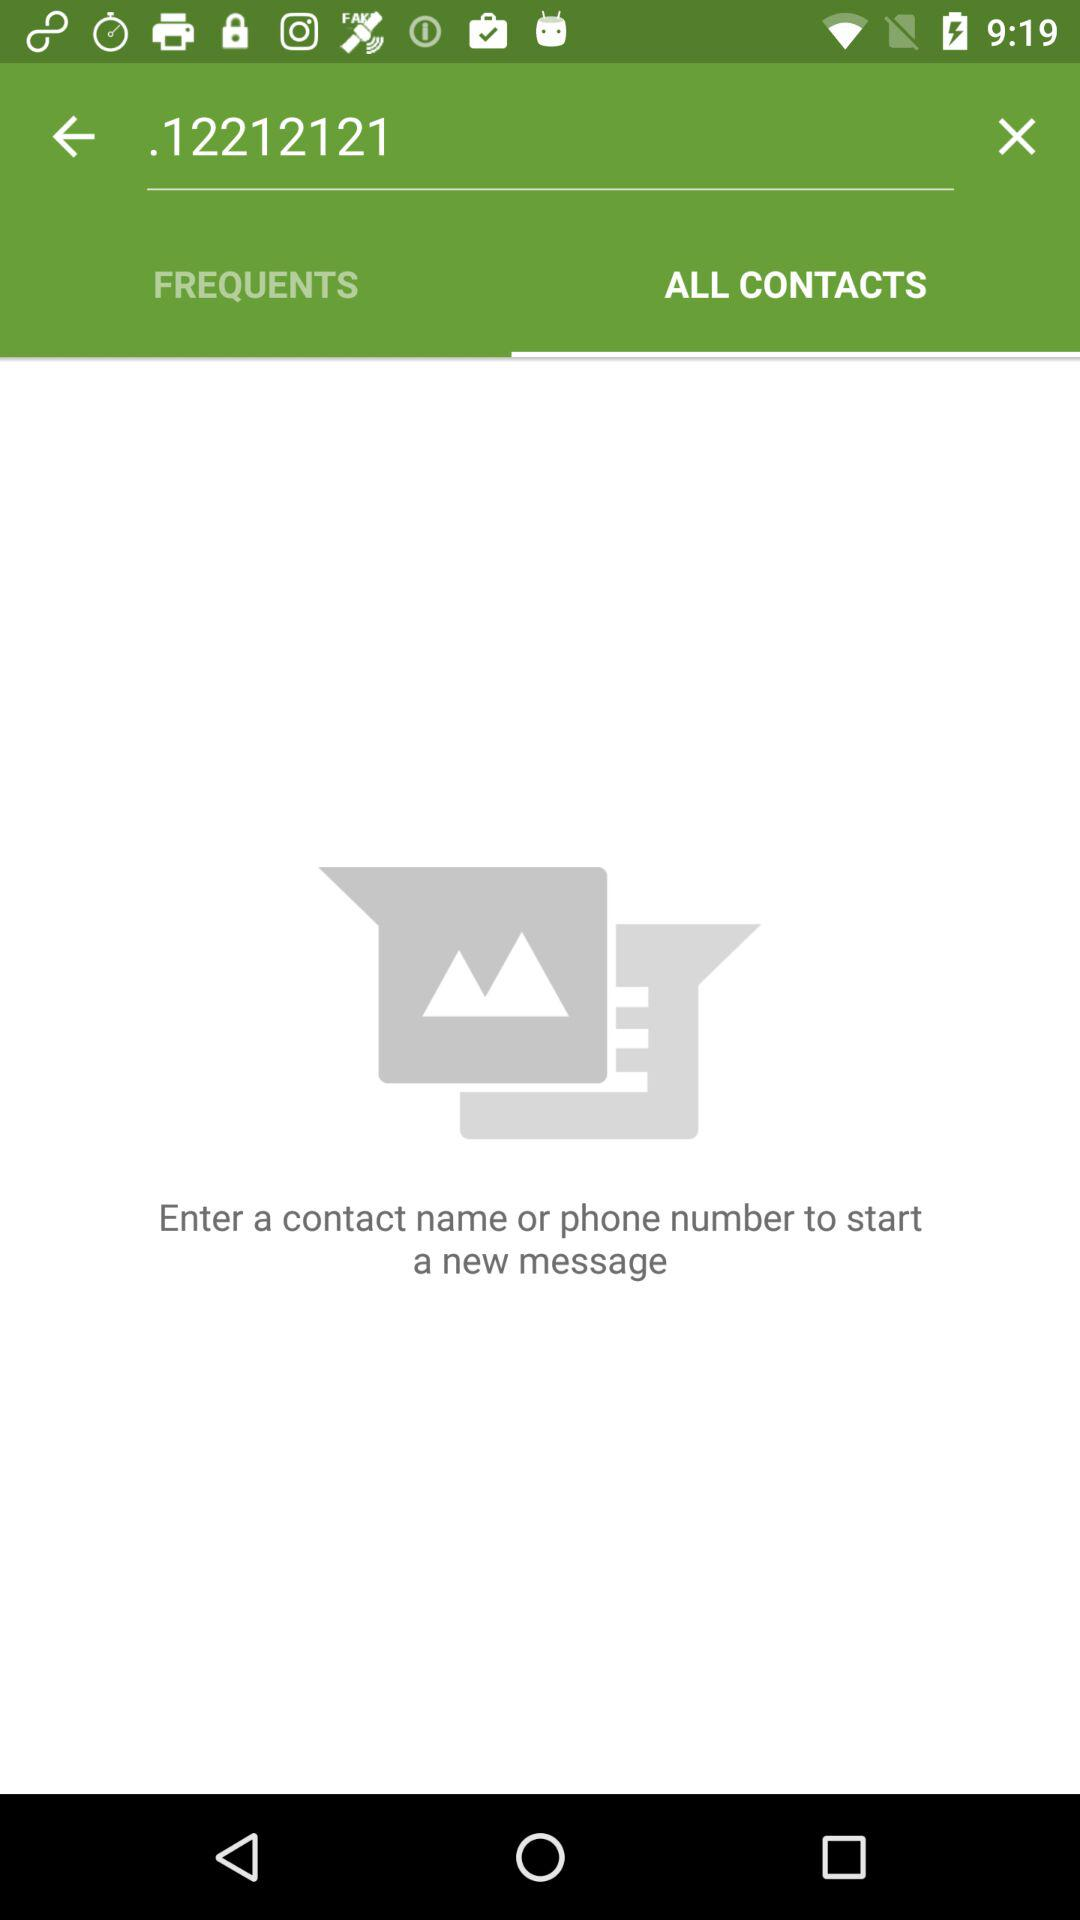Which tab is selected? The selected tab is "ALL CONTACTS". 